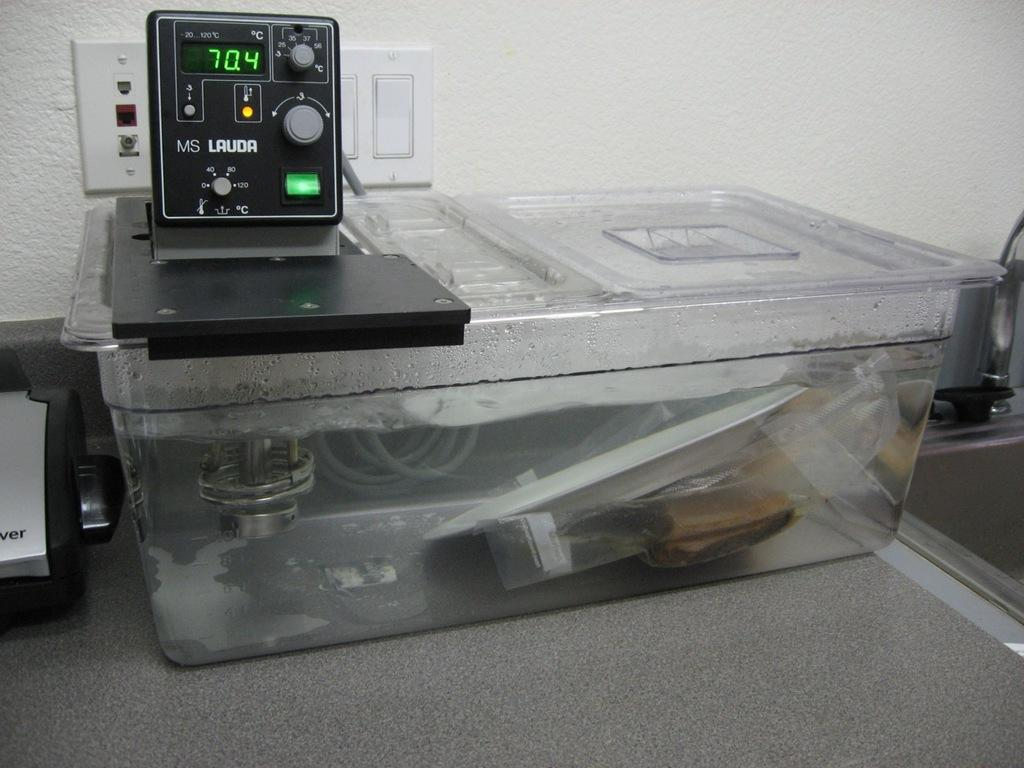<image>
Offer a succinct explanation of the picture presented. A device that reads a temperature of 70.4 